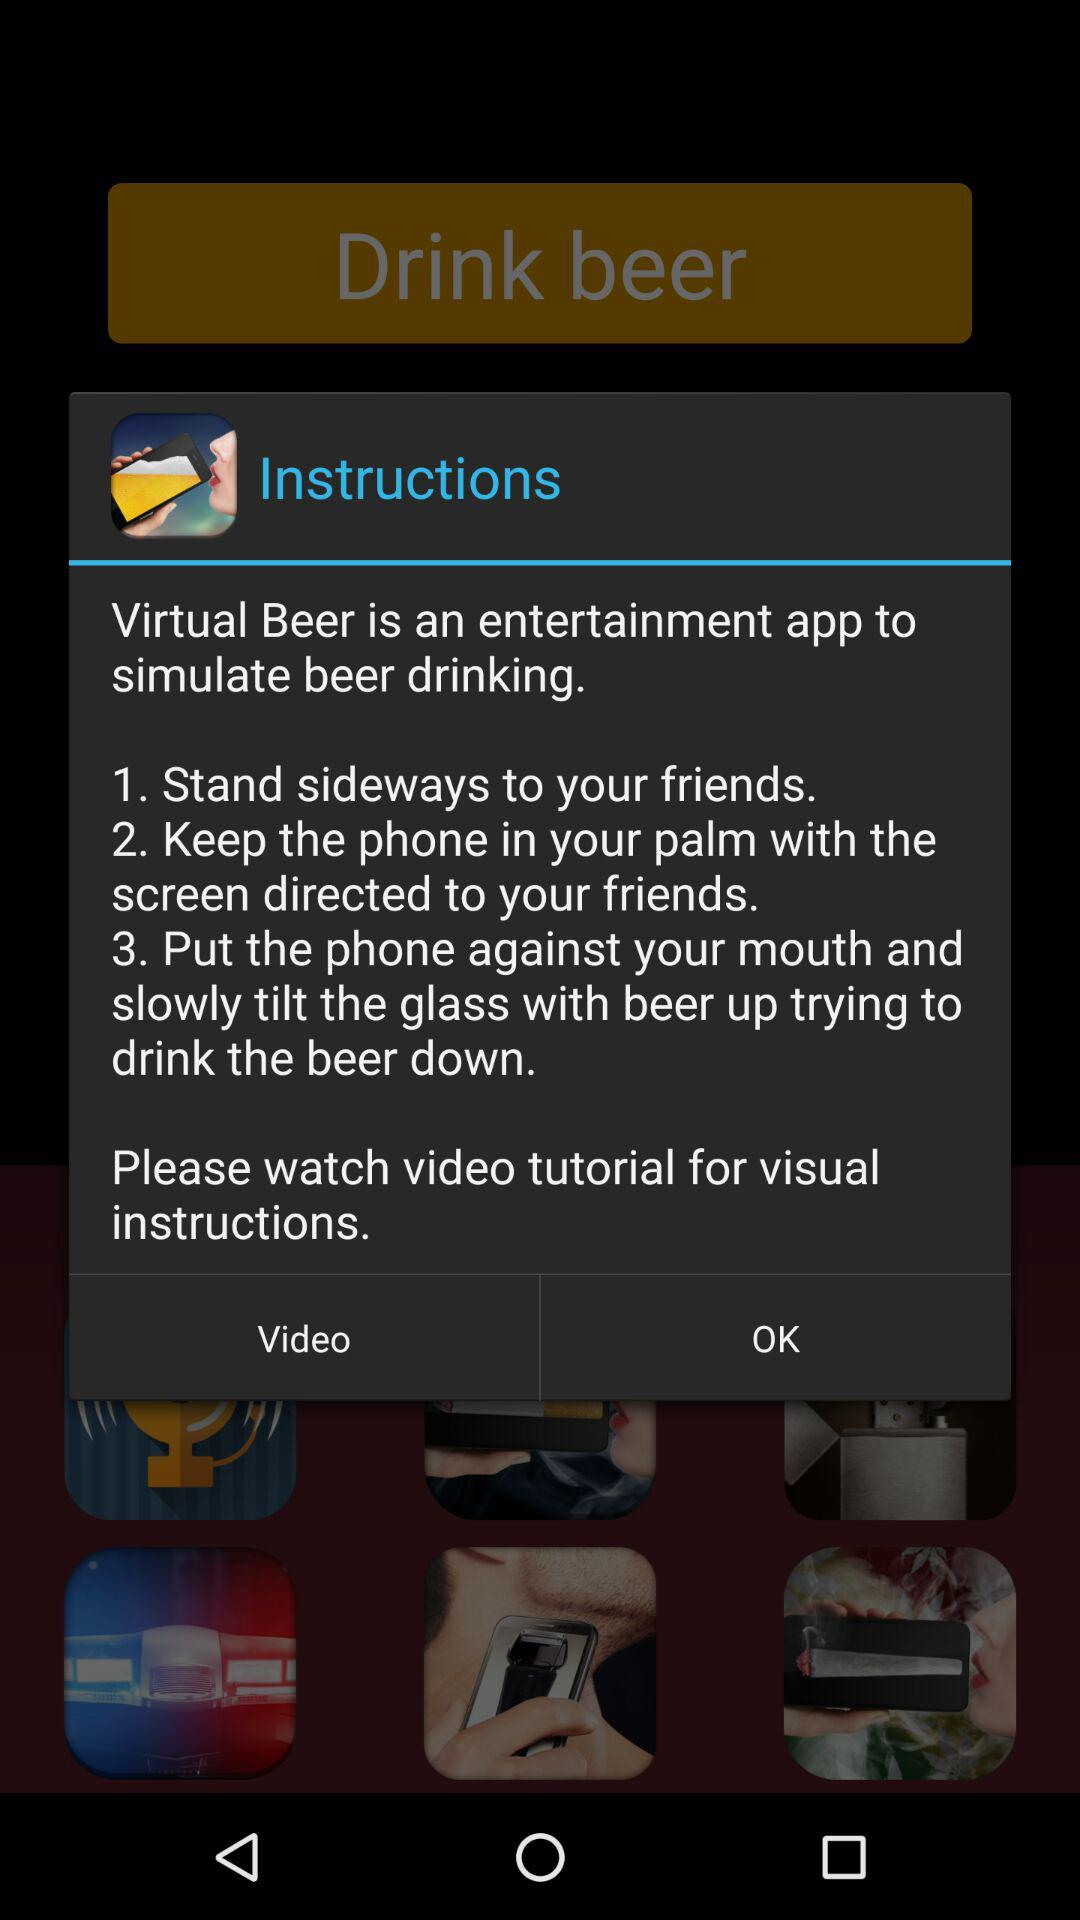How many steps are there in the instructions?
Answer the question using a single word or phrase. 3 